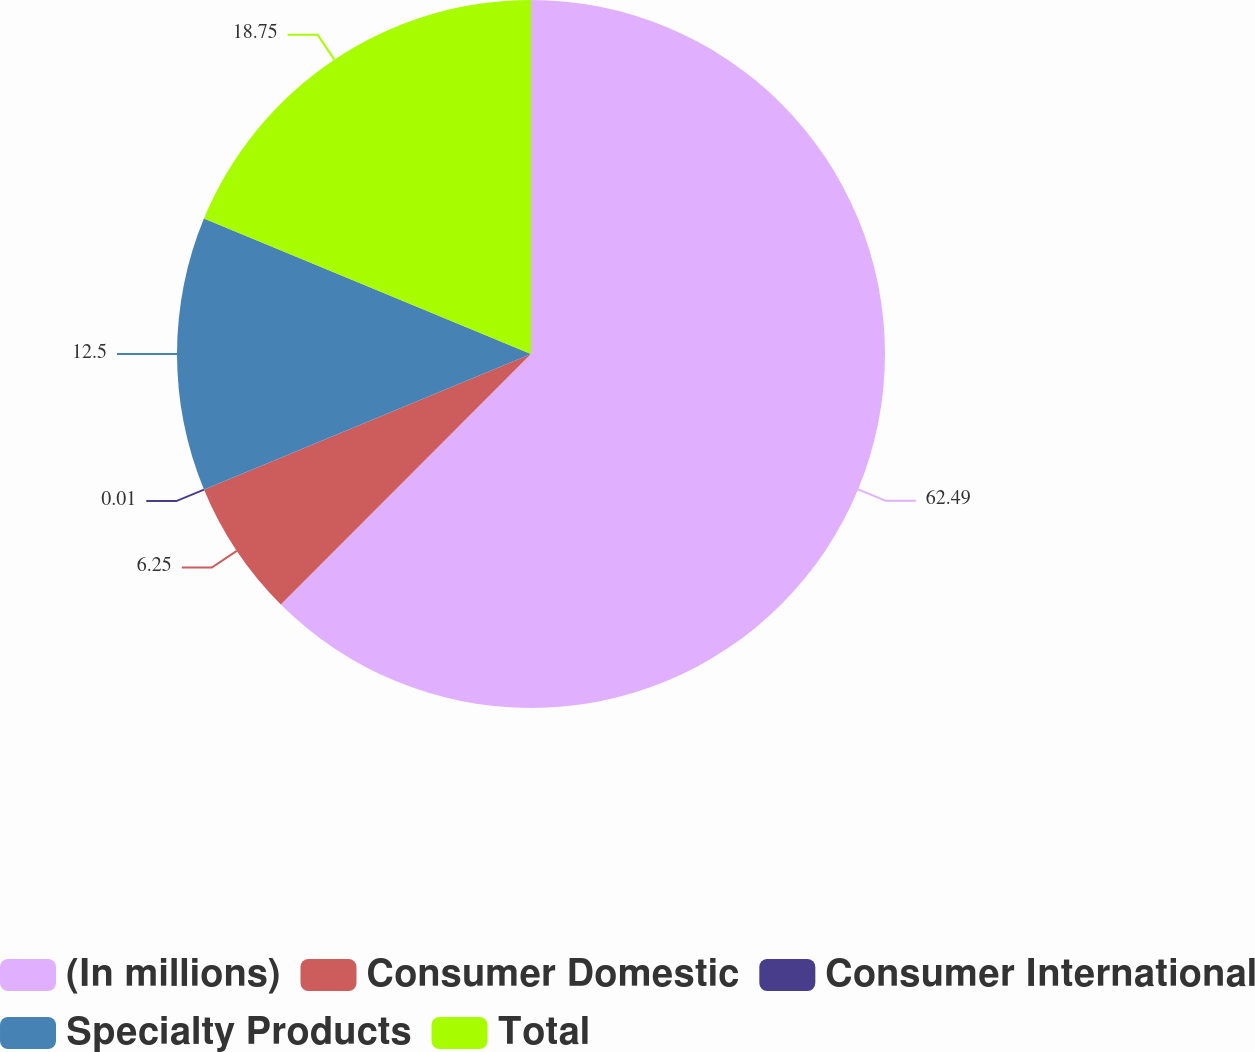Convert chart to OTSL. <chart><loc_0><loc_0><loc_500><loc_500><pie_chart><fcel>(In millions)<fcel>Consumer Domestic<fcel>Consumer International<fcel>Specialty Products<fcel>Total<nl><fcel>62.49%<fcel>6.25%<fcel>0.01%<fcel>12.5%<fcel>18.75%<nl></chart> 